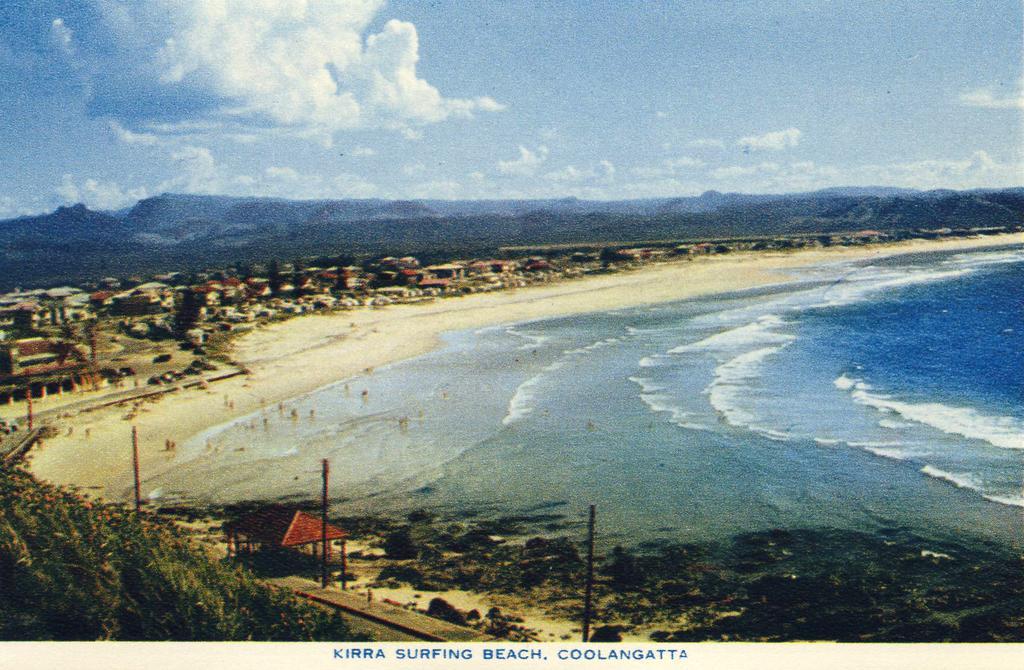Could you give a brief overview of what you see in this image? In this image, we can see water, we can see homes, there are some mountains, at the top there is a sky. 